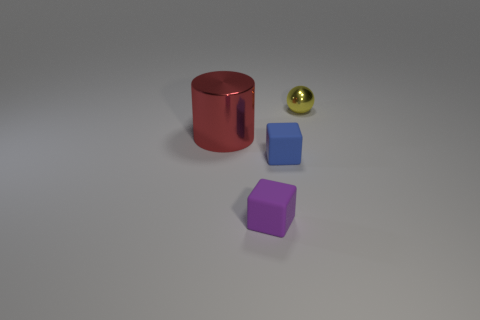There is a object that is behind the small blue matte block and on the left side of the yellow ball; what size is it?
Make the answer very short. Large. Are there more rubber blocks than objects?
Your response must be concise. No. How many other objects are the same size as the shiny cylinder?
Keep it short and to the point. 0. There is a big cylinder that is behind the matte block that is behind the block that is in front of the small blue rubber cube; what is its material?
Offer a very short reply. Metal. Is the tiny purple object made of the same material as the object right of the tiny blue cube?
Your response must be concise. No. Is the number of purple objects in front of the purple object less than the number of tiny purple blocks in front of the small blue matte object?
Give a very brief answer. Yes. How many tiny blue blocks have the same material as the red thing?
Your response must be concise. 0. Is there a metal object left of the metal object behind the shiny thing in front of the tiny yellow metal sphere?
Your answer should be very brief. Yes. What number of cylinders are either purple objects or cyan shiny things?
Your answer should be compact. 0. There is a blue rubber thing; does it have the same shape as the tiny matte object left of the blue rubber cube?
Provide a short and direct response. Yes. 